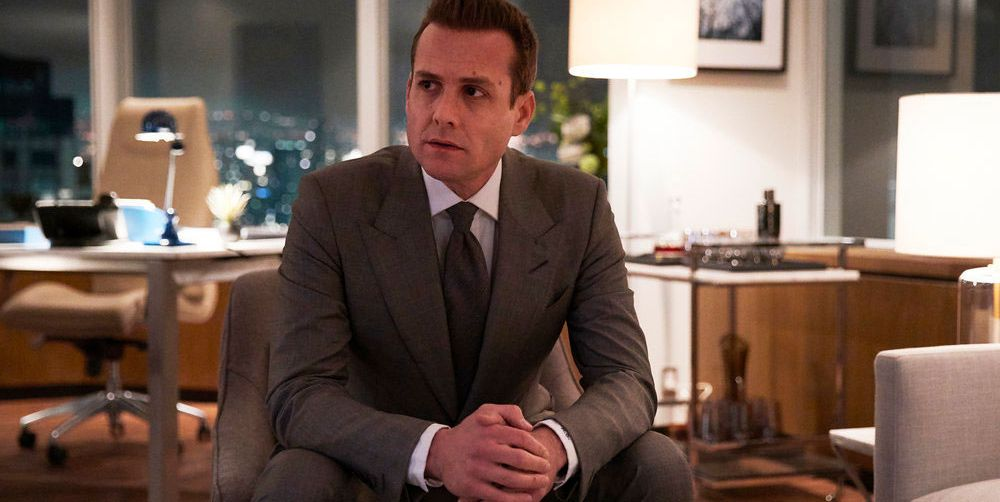What might be the possible thoughts or concerns on the man's mind in this setting? The man's thoughtful expression and focused gaze could imply that he is deep in contemplation about an important business decision or reflecting on the outcomes of a significant meeting. The late hour indicated by the night-time cityscape outside his window suggests he might be working overtime, possibly grappling with deadlines or preparing strategies for upcoming challenges. 